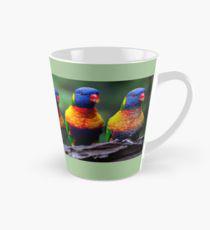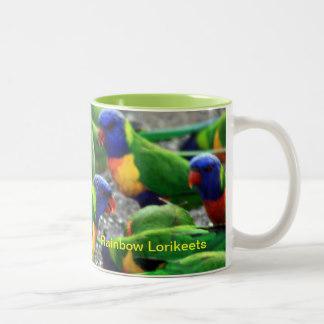The first image is the image on the left, the second image is the image on the right. For the images displayed, is the sentence "An image contains only one left-facing parrot perched on some object." factually correct? Answer yes or no. No. The first image is the image on the left, the second image is the image on the right. Evaluate the accuracy of this statement regarding the images: "There are no more than 3 birds.". Is it true? Answer yes or no. No. 